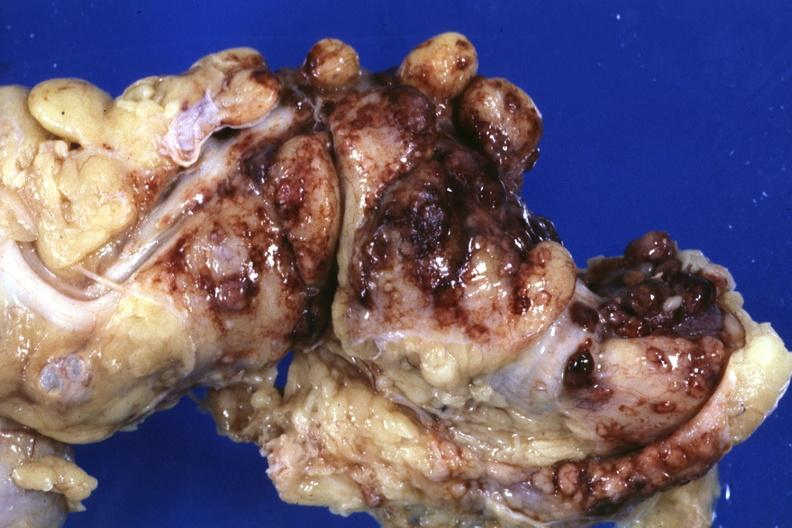what is present?
Answer the question using a single word or phrase. Abdomen 